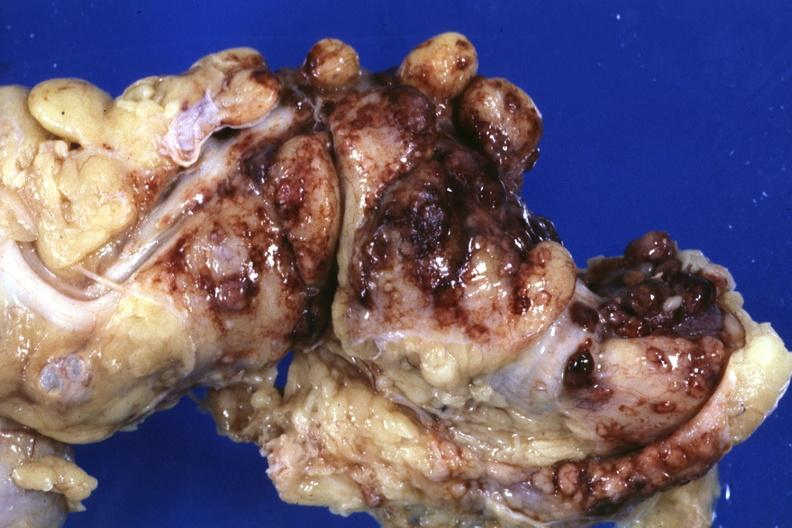what is present?
Answer the question using a single word or phrase. Abdomen 